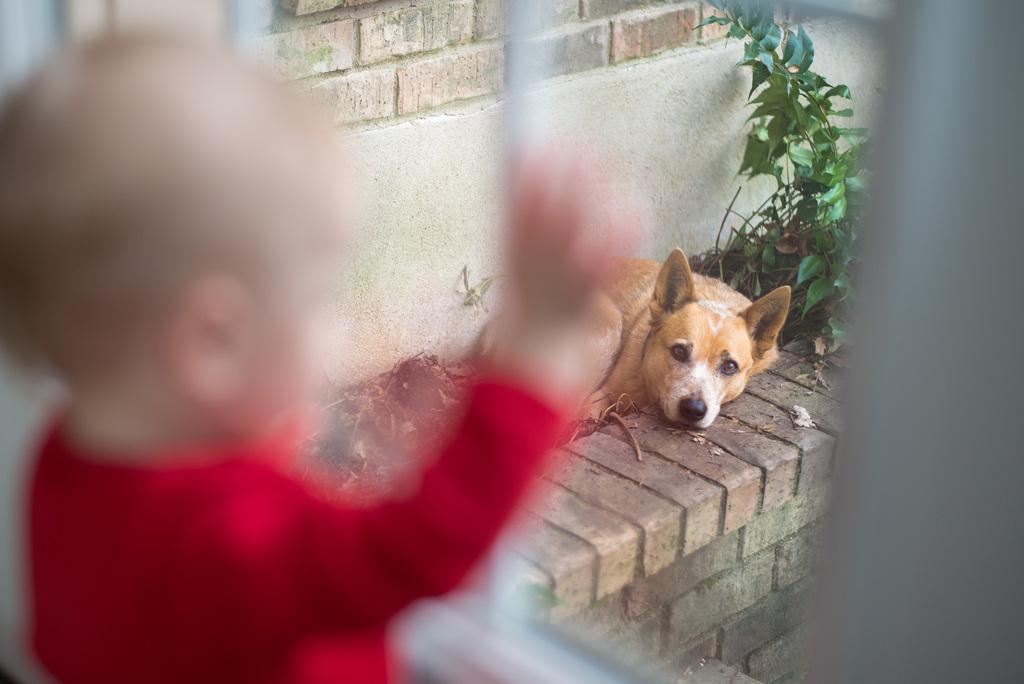In one or two sentences, can you explain what this image depicts? In this picture we can see a dog laying here, behind it there is a plant, on the left side we can see a kid, in the background there is a wall. 